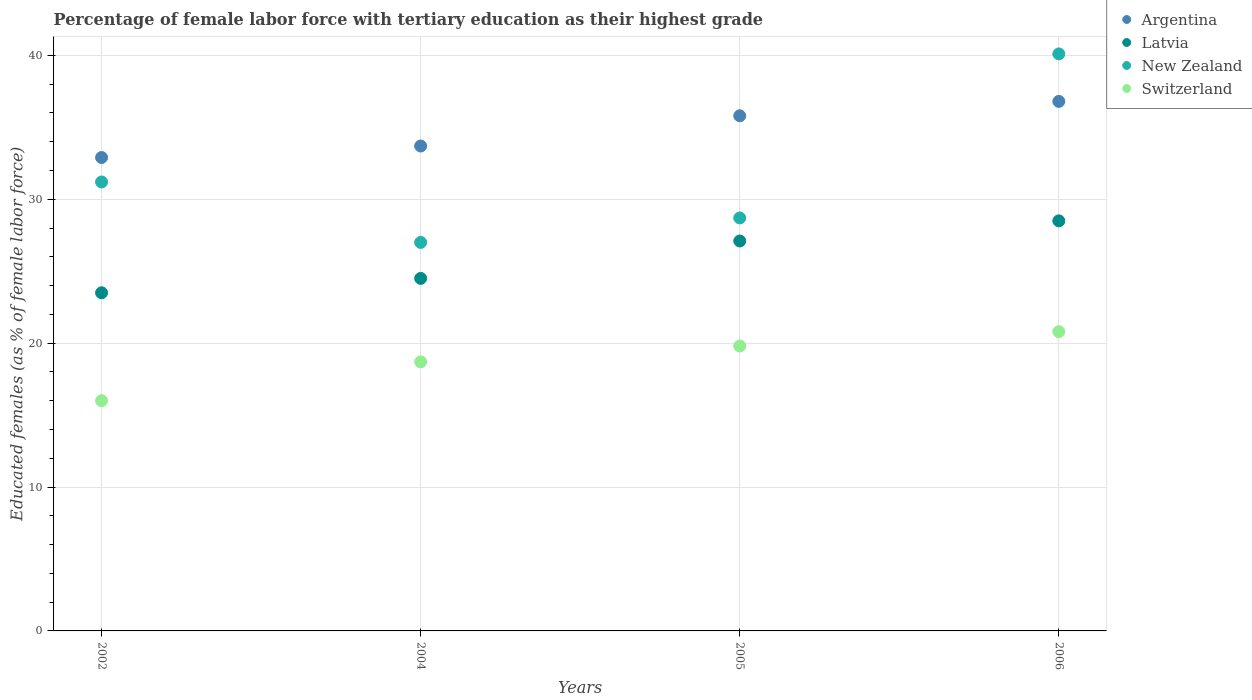Is the number of dotlines equal to the number of legend labels?
Your answer should be compact. Yes. What is the percentage of female labor force with tertiary education in Argentina in 2004?
Your answer should be compact. 33.7. Across all years, what is the maximum percentage of female labor force with tertiary education in Latvia?
Make the answer very short. 28.5. Across all years, what is the minimum percentage of female labor force with tertiary education in New Zealand?
Your answer should be very brief. 27. In which year was the percentage of female labor force with tertiary education in Latvia maximum?
Ensure brevity in your answer.  2006. In which year was the percentage of female labor force with tertiary education in Latvia minimum?
Provide a short and direct response. 2002. What is the total percentage of female labor force with tertiary education in Switzerland in the graph?
Ensure brevity in your answer.  75.3. What is the difference between the percentage of female labor force with tertiary education in Switzerland in 2002 and that in 2005?
Your answer should be very brief. -3.8. What is the difference between the percentage of female labor force with tertiary education in New Zealand in 2006 and the percentage of female labor force with tertiary education in Latvia in 2002?
Provide a succinct answer. 16.6. What is the average percentage of female labor force with tertiary education in Switzerland per year?
Make the answer very short. 18.82. In the year 2004, what is the difference between the percentage of female labor force with tertiary education in Latvia and percentage of female labor force with tertiary education in Switzerland?
Make the answer very short. 5.8. In how many years, is the percentage of female labor force with tertiary education in Argentina greater than 8 %?
Keep it short and to the point. 4. What is the ratio of the percentage of female labor force with tertiary education in Latvia in 2005 to that in 2006?
Offer a terse response. 0.95. Is the percentage of female labor force with tertiary education in New Zealand in 2002 less than that in 2005?
Keep it short and to the point. No. What is the difference between the highest and the second highest percentage of female labor force with tertiary education in New Zealand?
Offer a very short reply. 8.9. What is the difference between the highest and the lowest percentage of female labor force with tertiary education in Latvia?
Provide a short and direct response. 5. In how many years, is the percentage of female labor force with tertiary education in Argentina greater than the average percentage of female labor force with tertiary education in Argentina taken over all years?
Offer a very short reply. 2. Is it the case that in every year, the sum of the percentage of female labor force with tertiary education in Switzerland and percentage of female labor force with tertiary education in New Zealand  is greater than the sum of percentage of female labor force with tertiary education in Argentina and percentage of female labor force with tertiary education in Latvia?
Offer a very short reply. Yes. Is it the case that in every year, the sum of the percentage of female labor force with tertiary education in Argentina and percentage of female labor force with tertiary education in Switzerland  is greater than the percentage of female labor force with tertiary education in Latvia?
Make the answer very short. Yes. Does the percentage of female labor force with tertiary education in Switzerland monotonically increase over the years?
Provide a short and direct response. Yes. Is the percentage of female labor force with tertiary education in Switzerland strictly less than the percentage of female labor force with tertiary education in Argentina over the years?
Your answer should be compact. Yes. How many years are there in the graph?
Offer a terse response. 4. Does the graph contain grids?
Give a very brief answer. Yes. Where does the legend appear in the graph?
Keep it short and to the point. Top right. How are the legend labels stacked?
Offer a very short reply. Vertical. What is the title of the graph?
Offer a very short reply. Percentage of female labor force with tertiary education as their highest grade. Does "Azerbaijan" appear as one of the legend labels in the graph?
Give a very brief answer. No. What is the label or title of the X-axis?
Provide a succinct answer. Years. What is the label or title of the Y-axis?
Offer a terse response. Educated females (as % of female labor force). What is the Educated females (as % of female labor force) in Argentina in 2002?
Offer a very short reply. 32.9. What is the Educated females (as % of female labor force) of Latvia in 2002?
Provide a succinct answer. 23.5. What is the Educated females (as % of female labor force) of New Zealand in 2002?
Offer a very short reply. 31.2. What is the Educated females (as % of female labor force) in Switzerland in 2002?
Provide a succinct answer. 16. What is the Educated females (as % of female labor force) of Argentina in 2004?
Your response must be concise. 33.7. What is the Educated females (as % of female labor force) of Latvia in 2004?
Make the answer very short. 24.5. What is the Educated females (as % of female labor force) of New Zealand in 2004?
Provide a succinct answer. 27. What is the Educated females (as % of female labor force) of Switzerland in 2004?
Offer a terse response. 18.7. What is the Educated females (as % of female labor force) of Argentina in 2005?
Provide a short and direct response. 35.8. What is the Educated females (as % of female labor force) of Latvia in 2005?
Your response must be concise. 27.1. What is the Educated females (as % of female labor force) in New Zealand in 2005?
Provide a succinct answer. 28.7. What is the Educated females (as % of female labor force) of Switzerland in 2005?
Ensure brevity in your answer.  19.8. What is the Educated females (as % of female labor force) of Argentina in 2006?
Provide a short and direct response. 36.8. What is the Educated females (as % of female labor force) of Latvia in 2006?
Ensure brevity in your answer.  28.5. What is the Educated females (as % of female labor force) of New Zealand in 2006?
Offer a terse response. 40.1. What is the Educated females (as % of female labor force) of Switzerland in 2006?
Provide a short and direct response. 20.8. Across all years, what is the maximum Educated females (as % of female labor force) in Argentina?
Provide a short and direct response. 36.8. Across all years, what is the maximum Educated females (as % of female labor force) of Latvia?
Your response must be concise. 28.5. Across all years, what is the maximum Educated females (as % of female labor force) of New Zealand?
Offer a very short reply. 40.1. Across all years, what is the maximum Educated females (as % of female labor force) of Switzerland?
Ensure brevity in your answer.  20.8. Across all years, what is the minimum Educated females (as % of female labor force) of Argentina?
Your response must be concise. 32.9. Across all years, what is the minimum Educated females (as % of female labor force) in Latvia?
Your answer should be compact. 23.5. What is the total Educated females (as % of female labor force) in Argentina in the graph?
Your response must be concise. 139.2. What is the total Educated females (as % of female labor force) of Latvia in the graph?
Make the answer very short. 103.6. What is the total Educated females (as % of female labor force) of New Zealand in the graph?
Make the answer very short. 127. What is the total Educated females (as % of female labor force) of Switzerland in the graph?
Your answer should be very brief. 75.3. What is the difference between the Educated females (as % of female labor force) in Argentina in 2002 and that in 2004?
Your response must be concise. -0.8. What is the difference between the Educated females (as % of female labor force) of New Zealand in 2002 and that in 2004?
Your response must be concise. 4.2. What is the difference between the Educated females (as % of female labor force) of Latvia in 2002 and that in 2005?
Offer a terse response. -3.6. What is the difference between the Educated females (as % of female labor force) in New Zealand in 2002 and that in 2005?
Offer a terse response. 2.5. What is the difference between the Educated females (as % of female labor force) in Argentina in 2002 and that in 2006?
Your answer should be very brief. -3.9. What is the difference between the Educated females (as % of female labor force) of Latvia in 2002 and that in 2006?
Provide a succinct answer. -5. What is the difference between the Educated females (as % of female labor force) in New Zealand in 2002 and that in 2006?
Ensure brevity in your answer.  -8.9. What is the difference between the Educated females (as % of female labor force) in New Zealand in 2004 and that in 2005?
Keep it short and to the point. -1.7. What is the difference between the Educated females (as % of female labor force) in New Zealand in 2004 and that in 2006?
Ensure brevity in your answer.  -13.1. What is the difference between the Educated females (as % of female labor force) in Switzerland in 2004 and that in 2006?
Your response must be concise. -2.1. What is the difference between the Educated females (as % of female labor force) in Argentina in 2002 and the Educated females (as % of female labor force) in New Zealand in 2004?
Make the answer very short. 5.9. What is the difference between the Educated females (as % of female labor force) of Argentina in 2002 and the Educated females (as % of female labor force) of Switzerland in 2004?
Provide a succinct answer. 14.2. What is the difference between the Educated females (as % of female labor force) of Latvia in 2002 and the Educated females (as % of female labor force) of New Zealand in 2004?
Keep it short and to the point. -3.5. What is the difference between the Educated females (as % of female labor force) in Latvia in 2002 and the Educated females (as % of female labor force) in Switzerland in 2004?
Your answer should be compact. 4.8. What is the difference between the Educated females (as % of female labor force) of New Zealand in 2002 and the Educated females (as % of female labor force) of Switzerland in 2004?
Your response must be concise. 12.5. What is the difference between the Educated females (as % of female labor force) in Argentina in 2002 and the Educated females (as % of female labor force) in Latvia in 2005?
Make the answer very short. 5.8. What is the difference between the Educated females (as % of female labor force) in Argentina in 2002 and the Educated females (as % of female labor force) in New Zealand in 2005?
Give a very brief answer. 4.2. What is the difference between the Educated females (as % of female labor force) of Argentina in 2002 and the Educated females (as % of female labor force) of Switzerland in 2005?
Ensure brevity in your answer.  13.1. What is the difference between the Educated females (as % of female labor force) of Latvia in 2002 and the Educated females (as % of female labor force) of Switzerland in 2005?
Make the answer very short. 3.7. What is the difference between the Educated females (as % of female labor force) of New Zealand in 2002 and the Educated females (as % of female labor force) of Switzerland in 2005?
Offer a very short reply. 11.4. What is the difference between the Educated females (as % of female labor force) in Argentina in 2002 and the Educated females (as % of female labor force) in Latvia in 2006?
Make the answer very short. 4.4. What is the difference between the Educated females (as % of female labor force) of Latvia in 2002 and the Educated females (as % of female labor force) of New Zealand in 2006?
Provide a succinct answer. -16.6. What is the difference between the Educated females (as % of female labor force) in New Zealand in 2002 and the Educated females (as % of female labor force) in Switzerland in 2006?
Your answer should be very brief. 10.4. What is the difference between the Educated females (as % of female labor force) of Argentina in 2004 and the Educated females (as % of female labor force) of Latvia in 2005?
Offer a terse response. 6.6. What is the difference between the Educated females (as % of female labor force) of Latvia in 2004 and the Educated females (as % of female labor force) of Switzerland in 2005?
Keep it short and to the point. 4.7. What is the difference between the Educated females (as % of female labor force) in Argentina in 2004 and the Educated females (as % of female labor force) in Switzerland in 2006?
Keep it short and to the point. 12.9. What is the difference between the Educated females (as % of female labor force) in Latvia in 2004 and the Educated females (as % of female labor force) in New Zealand in 2006?
Make the answer very short. -15.6. What is the difference between the Educated females (as % of female labor force) in New Zealand in 2004 and the Educated females (as % of female labor force) in Switzerland in 2006?
Make the answer very short. 6.2. What is the difference between the Educated females (as % of female labor force) in Argentina in 2005 and the Educated females (as % of female labor force) in Latvia in 2006?
Offer a terse response. 7.3. What is the difference between the Educated females (as % of female labor force) of Argentina in 2005 and the Educated females (as % of female labor force) of Switzerland in 2006?
Your answer should be very brief. 15. What is the difference between the Educated females (as % of female labor force) of Latvia in 2005 and the Educated females (as % of female labor force) of Switzerland in 2006?
Ensure brevity in your answer.  6.3. What is the difference between the Educated females (as % of female labor force) of New Zealand in 2005 and the Educated females (as % of female labor force) of Switzerland in 2006?
Your answer should be very brief. 7.9. What is the average Educated females (as % of female labor force) in Argentina per year?
Offer a terse response. 34.8. What is the average Educated females (as % of female labor force) of Latvia per year?
Your answer should be very brief. 25.9. What is the average Educated females (as % of female labor force) in New Zealand per year?
Keep it short and to the point. 31.75. What is the average Educated females (as % of female labor force) of Switzerland per year?
Offer a terse response. 18.82. In the year 2002, what is the difference between the Educated females (as % of female labor force) in Argentina and Educated females (as % of female labor force) in Latvia?
Keep it short and to the point. 9.4. In the year 2002, what is the difference between the Educated females (as % of female labor force) of Latvia and Educated females (as % of female labor force) of New Zealand?
Give a very brief answer. -7.7. In the year 2004, what is the difference between the Educated females (as % of female labor force) of Argentina and Educated females (as % of female labor force) of Switzerland?
Provide a succinct answer. 15. In the year 2004, what is the difference between the Educated females (as % of female labor force) of Latvia and Educated females (as % of female labor force) of Switzerland?
Your answer should be compact. 5.8. In the year 2005, what is the difference between the Educated females (as % of female labor force) of Argentina and Educated females (as % of female labor force) of Latvia?
Your answer should be very brief. 8.7. In the year 2005, what is the difference between the Educated females (as % of female labor force) of Argentina and Educated females (as % of female labor force) of New Zealand?
Offer a terse response. 7.1. In the year 2005, what is the difference between the Educated females (as % of female labor force) of Argentina and Educated females (as % of female labor force) of Switzerland?
Ensure brevity in your answer.  16. In the year 2005, what is the difference between the Educated females (as % of female labor force) in New Zealand and Educated females (as % of female labor force) in Switzerland?
Your answer should be compact. 8.9. In the year 2006, what is the difference between the Educated females (as % of female labor force) in Argentina and Educated females (as % of female labor force) in Latvia?
Your response must be concise. 8.3. In the year 2006, what is the difference between the Educated females (as % of female labor force) in Argentina and Educated females (as % of female labor force) in Switzerland?
Provide a short and direct response. 16. In the year 2006, what is the difference between the Educated females (as % of female labor force) in Latvia and Educated females (as % of female labor force) in New Zealand?
Your answer should be compact. -11.6. In the year 2006, what is the difference between the Educated females (as % of female labor force) of New Zealand and Educated females (as % of female labor force) of Switzerland?
Provide a succinct answer. 19.3. What is the ratio of the Educated females (as % of female labor force) of Argentina in 2002 to that in 2004?
Give a very brief answer. 0.98. What is the ratio of the Educated females (as % of female labor force) of Latvia in 2002 to that in 2004?
Provide a succinct answer. 0.96. What is the ratio of the Educated females (as % of female labor force) in New Zealand in 2002 to that in 2004?
Keep it short and to the point. 1.16. What is the ratio of the Educated females (as % of female labor force) in Switzerland in 2002 to that in 2004?
Your response must be concise. 0.86. What is the ratio of the Educated females (as % of female labor force) in Argentina in 2002 to that in 2005?
Keep it short and to the point. 0.92. What is the ratio of the Educated females (as % of female labor force) in Latvia in 2002 to that in 2005?
Your answer should be very brief. 0.87. What is the ratio of the Educated females (as % of female labor force) in New Zealand in 2002 to that in 2005?
Your answer should be compact. 1.09. What is the ratio of the Educated females (as % of female labor force) in Switzerland in 2002 to that in 2005?
Give a very brief answer. 0.81. What is the ratio of the Educated females (as % of female labor force) of Argentina in 2002 to that in 2006?
Provide a short and direct response. 0.89. What is the ratio of the Educated females (as % of female labor force) of Latvia in 2002 to that in 2006?
Ensure brevity in your answer.  0.82. What is the ratio of the Educated females (as % of female labor force) of New Zealand in 2002 to that in 2006?
Offer a very short reply. 0.78. What is the ratio of the Educated females (as % of female labor force) in Switzerland in 2002 to that in 2006?
Offer a terse response. 0.77. What is the ratio of the Educated females (as % of female labor force) in Argentina in 2004 to that in 2005?
Offer a terse response. 0.94. What is the ratio of the Educated females (as % of female labor force) of Latvia in 2004 to that in 2005?
Provide a succinct answer. 0.9. What is the ratio of the Educated females (as % of female labor force) in New Zealand in 2004 to that in 2005?
Provide a succinct answer. 0.94. What is the ratio of the Educated females (as % of female labor force) in Switzerland in 2004 to that in 2005?
Make the answer very short. 0.94. What is the ratio of the Educated females (as % of female labor force) in Argentina in 2004 to that in 2006?
Offer a very short reply. 0.92. What is the ratio of the Educated females (as % of female labor force) in Latvia in 2004 to that in 2006?
Ensure brevity in your answer.  0.86. What is the ratio of the Educated females (as % of female labor force) in New Zealand in 2004 to that in 2006?
Your response must be concise. 0.67. What is the ratio of the Educated females (as % of female labor force) of Switzerland in 2004 to that in 2006?
Offer a very short reply. 0.9. What is the ratio of the Educated females (as % of female labor force) of Argentina in 2005 to that in 2006?
Ensure brevity in your answer.  0.97. What is the ratio of the Educated females (as % of female labor force) in Latvia in 2005 to that in 2006?
Keep it short and to the point. 0.95. What is the ratio of the Educated females (as % of female labor force) of New Zealand in 2005 to that in 2006?
Your answer should be compact. 0.72. What is the ratio of the Educated females (as % of female labor force) in Switzerland in 2005 to that in 2006?
Make the answer very short. 0.95. What is the difference between the highest and the second highest Educated females (as % of female labor force) in Argentina?
Your answer should be very brief. 1. What is the difference between the highest and the second highest Educated females (as % of female labor force) in Switzerland?
Your answer should be compact. 1. What is the difference between the highest and the lowest Educated females (as % of female labor force) of Argentina?
Your answer should be very brief. 3.9. What is the difference between the highest and the lowest Educated females (as % of female labor force) of Latvia?
Your answer should be compact. 5. 